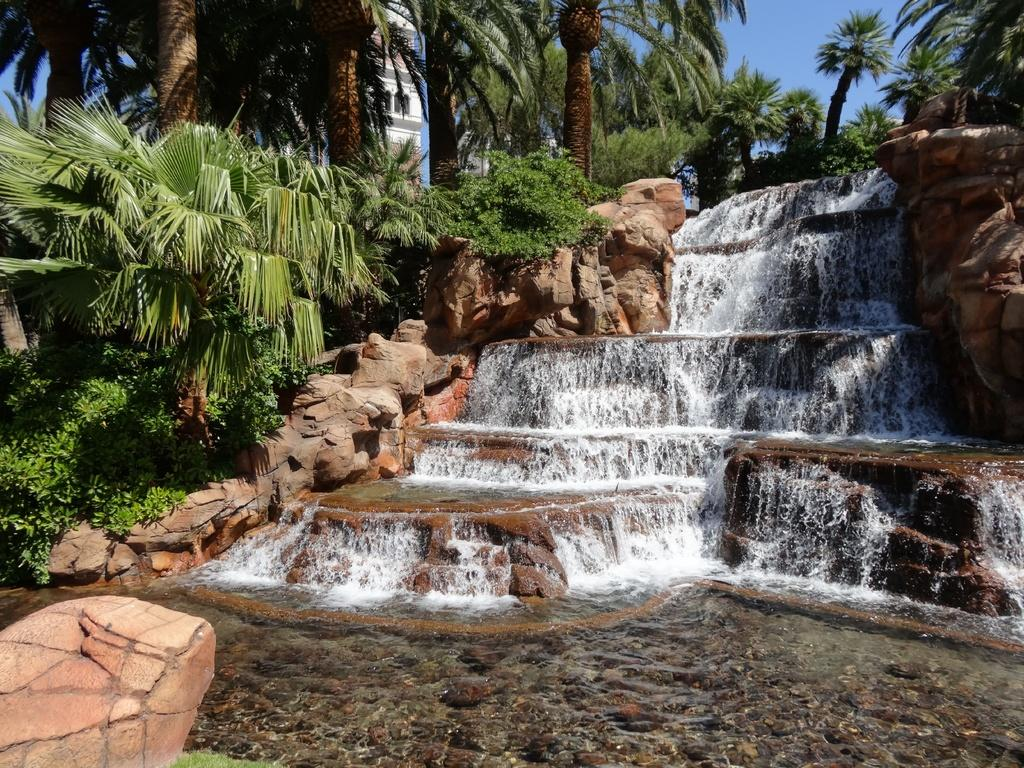What type of natural features can be seen in the image? There are trees, waterfalls, and rocks visible in the image. What type of vegetation is present in the image? There are plants in the image. What type of man-made structure is present in the image? There is a building in the image. What part of the natural environment is visible at the top of the image? The sky is visible at the top of the image. What part of the natural environment is visible at the bottom of the image? Water is visible at the bottom of the image. Where is the mailbox located in the image? There is no mailbox present in the image. Who is the expert in the image? There is no expert present in the image. What historical event is depicted in the image? There is no historical event depicted in the image. 